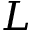<formula> <loc_0><loc_0><loc_500><loc_500>L</formula> 